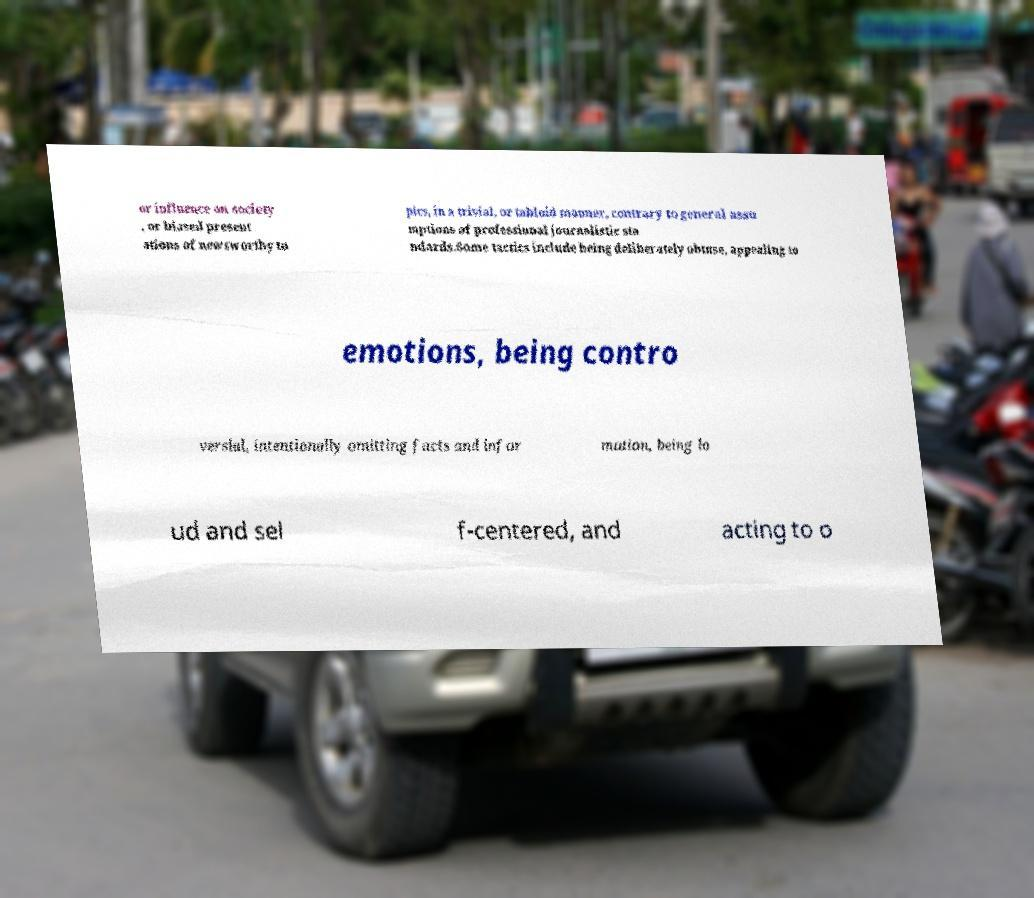Please identify and transcribe the text found in this image. or influence on society , or biased present ations of newsworthy to pics, in a trivial, or tabloid manner, contrary to general assu mptions of professional journalistic sta ndards.Some tactics include being deliberately obtuse, appealing to emotions, being contro versial, intentionally omitting facts and infor mation, being lo ud and sel f-centered, and acting to o 